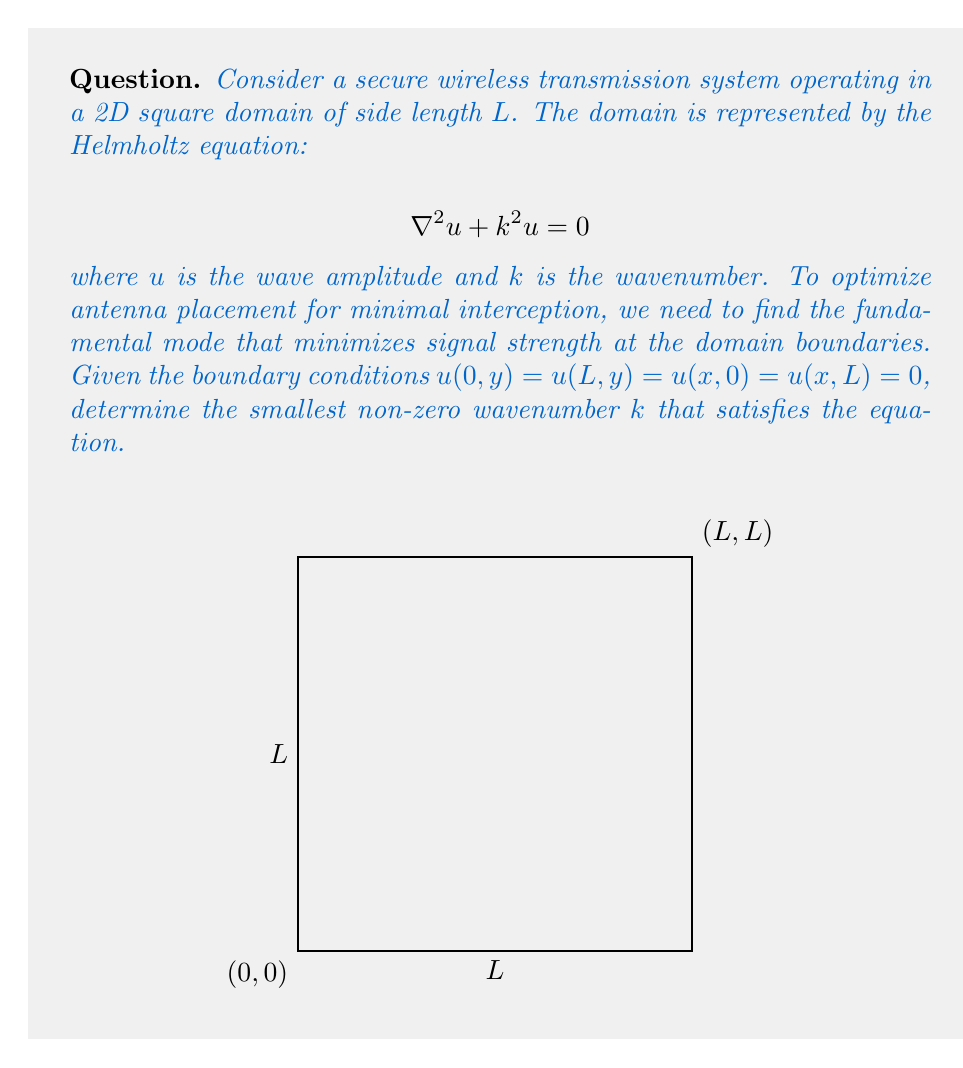Teach me how to tackle this problem. To solve this problem, we follow these steps:

1) The general solution for the 2D Helmholtz equation in rectangular coordinates is:

   $$u(x,y) = (A \sin(k_x x) + B \cos(k_x x))(C \sin(k_y y) + D \cos(k_y y))$$

2) Applying the boundary conditions:
   
   $u(0,y) = 0$ implies $B = 0$
   $u(L,y) = 0$ implies $\sin(k_x L) = 0$, so $k_x = \frac{n\pi}{L}$, where $n$ is a positive integer
   
   Similarly, $u(x,0) = 0$ and $u(x,L) = 0$ imply $D = 0$ and $k_y = \frac{m\pi}{L}$, where $m$ is a positive integer

3) The solution becomes:

   $$u(x,y) = A C \sin(\frac{n\pi x}{L}) \sin(\frac{m\pi y}{L})$$

4) Substituting this into the Helmholtz equation:

   $$-(\frac{n\pi}{L})^2 - (\frac{m\pi}{L})^2 + k^2 = 0$$

5) Solving for $k$:

   $$k^2 = (\frac{n\pi}{L})^2 + (\frac{m\pi}{L})^2 = \frac{\pi^2}{L^2}(n^2 + m^2)$$

6) The smallest non-zero wavenumber occurs when $n = m = 1$:

   $$k = \frac{\pi\sqrt{2}}{L}$$

This represents the fundamental mode that minimizes signal strength at the boundaries, optimizing antenna placement for secure transmission.
Answer: $\frac{\pi\sqrt{2}}{L}$ 